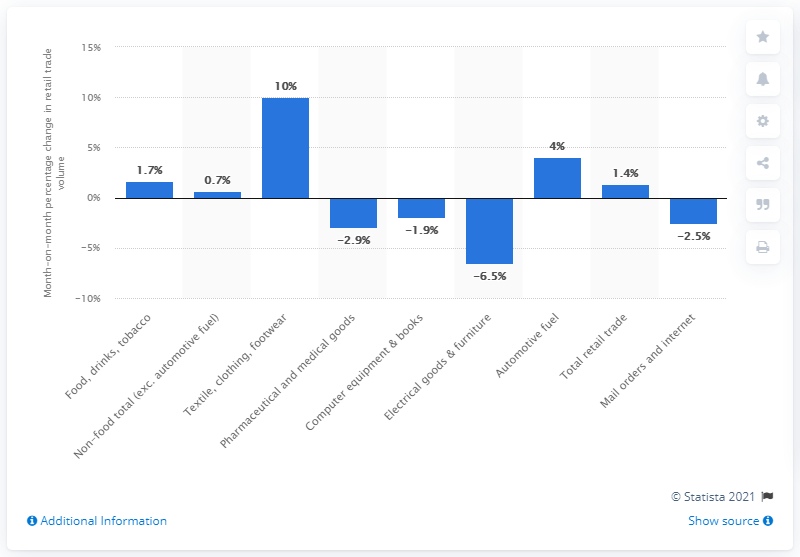List a handful of essential elements in this visual. The retail trade volume in the textile, clothing, and footwear category increased significantly in December 2020, with a growth of 10%. 